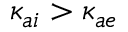Convert formula to latex. <formula><loc_0><loc_0><loc_500><loc_500>\kappa _ { a i } > \kappa _ { a e }</formula> 